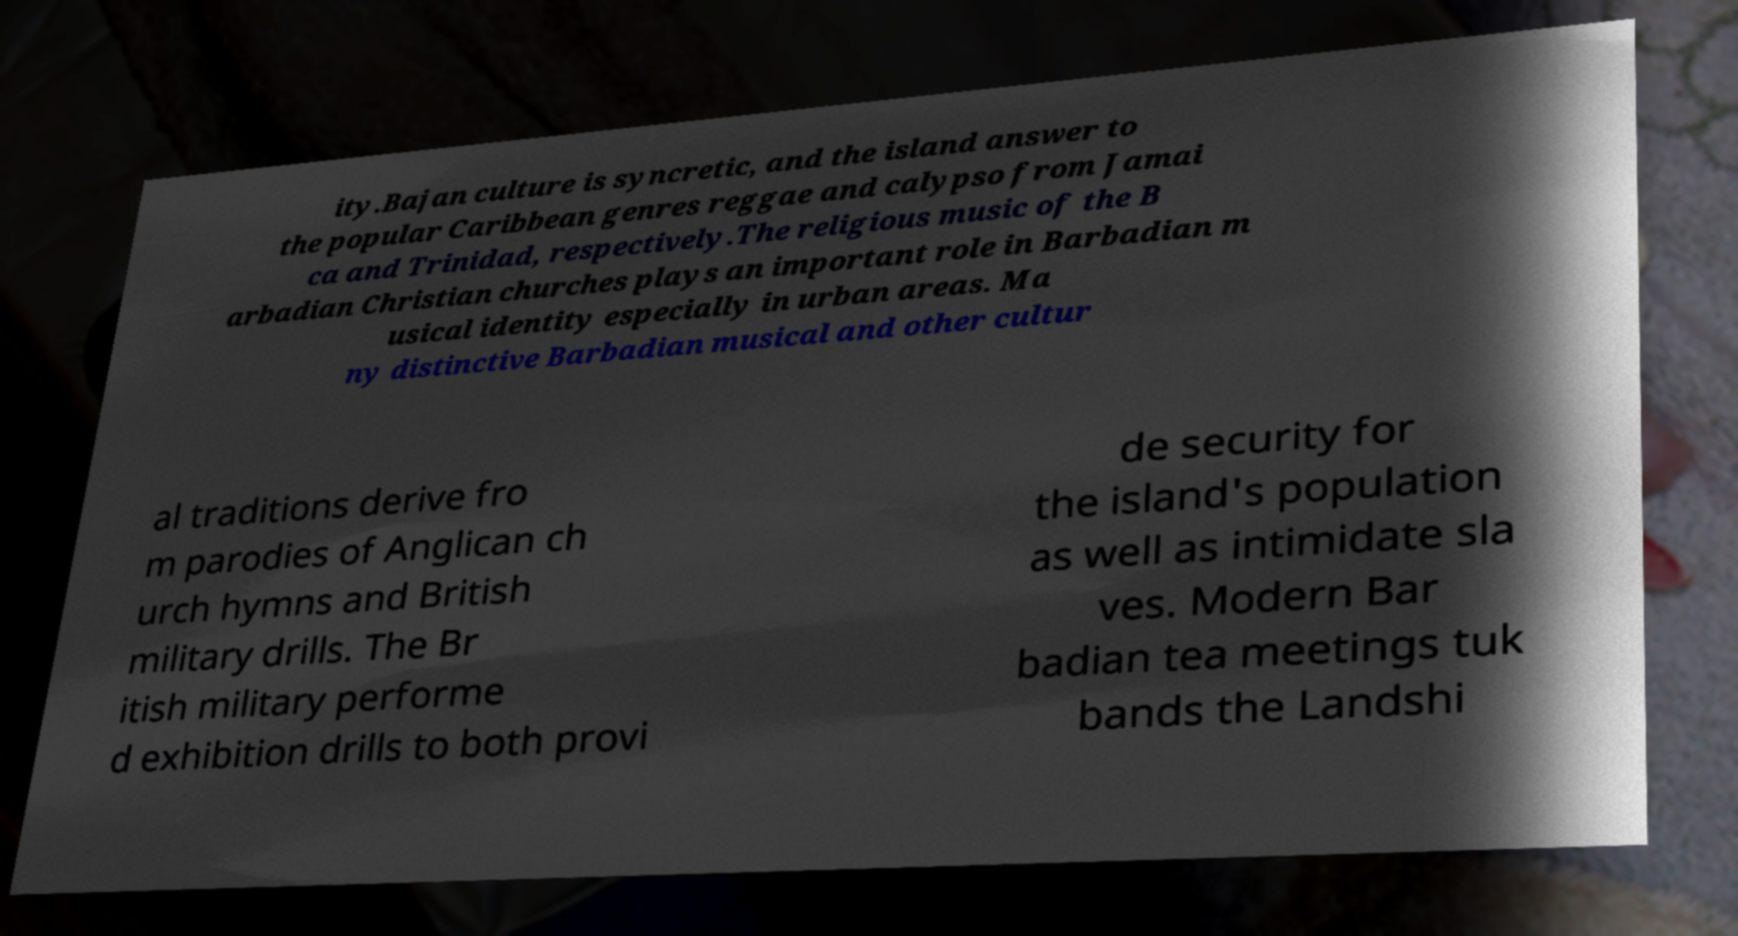Could you assist in decoding the text presented in this image and type it out clearly? ity.Bajan culture is syncretic, and the island answer to the popular Caribbean genres reggae and calypso from Jamai ca and Trinidad, respectively.The religious music of the B arbadian Christian churches plays an important role in Barbadian m usical identity especially in urban areas. Ma ny distinctive Barbadian musical and other cultur al traditions derive fro m parodies of Anglican ch urch hymns and British military drills. The Br itish military performe d exhibition drills to both provi de security for the island's population as well as intimidate sla ves. Modern Bar badian tea meetings tuk bands the Landshi 